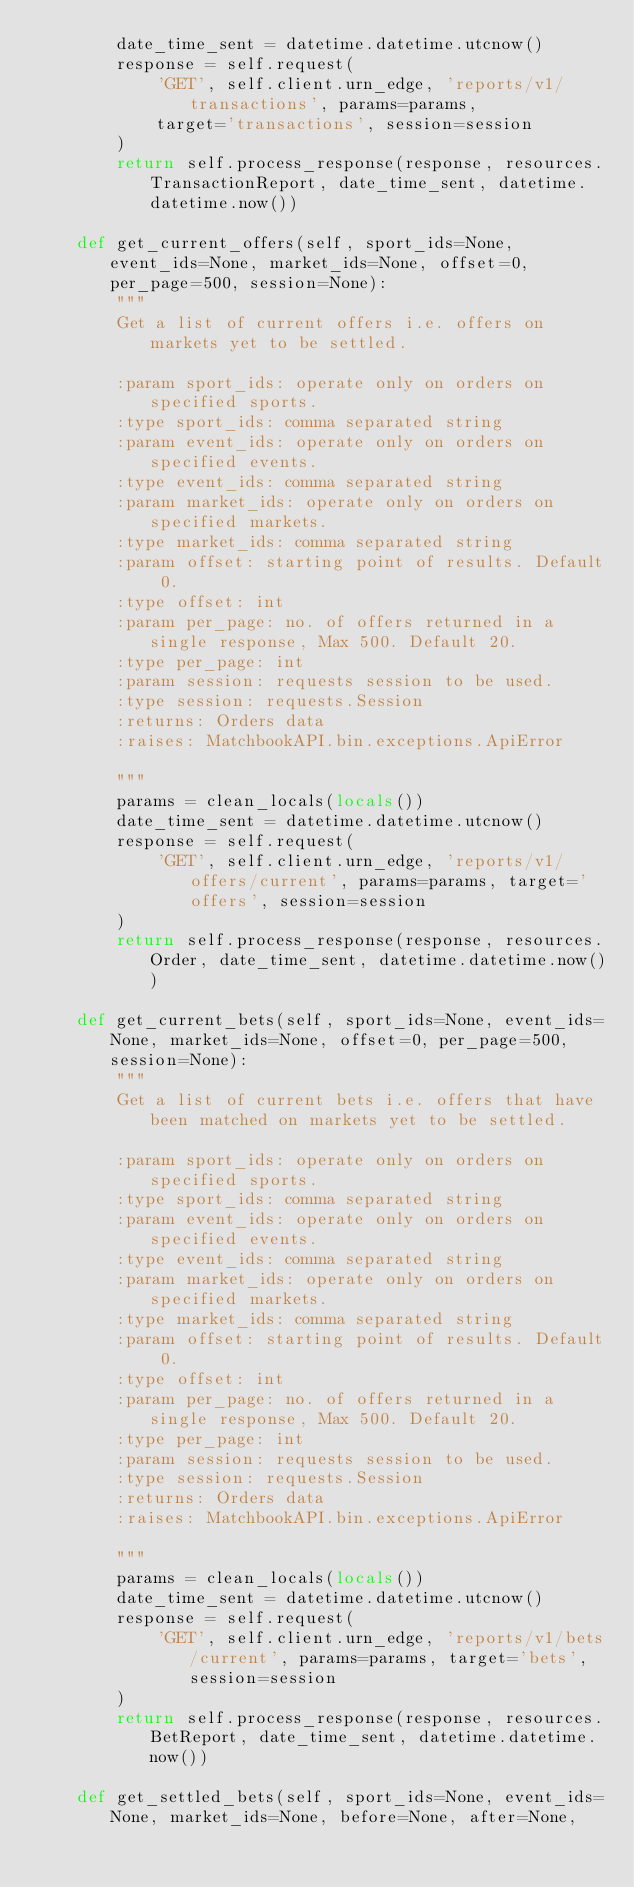<code> <loc_0><loc_0><loc_500><loc_500><_Python_>        date_time_sent = datetime.datetime.utcnow()
        response = self.request(
            'GET', self.client.urn_edge, 'reports/v1/transactions', params=params,
            target='transactions', session=session
        )
        return self.process_response(response, resources.TransactionReport, date_time_sent, datetime.datetime.now())

    def get_current_offers(self, sport_ids=None, event_ids=None, market_ids=None, offset=0, per_page=500, session=None):
        """
        Get a list of current offers i.e. offers on markets yet to be settled.
        
        :param sport_ids: operate only on orders on specified sports.
        :type sport_ids: comma separated string
        :param event_ids: operate only on orders on specified events.
        :type event_ids: comma separated string
        :param market_ids: operate only on orders on specified markets.
        :type market_ids: comma separated string
        :param offset: starting point of results. Default 0.
        :type offset: int
        :param per_page: no. of offers returned in a single response, Max 500. Default 20.
        :type per_page: int
        :param session: requests session to be used.
        :type session: requests.Session
        :returns: Orders data
        :raises: MatchbookAPI.bin.exceptions.ApiError

        """
        params = clean_locals(locals())
        date_time_sent = datetime.datetime.utcnow()
        response = self.request(
            'GET', self.client.urn_edge, 'reports/v1/offers/current', params=params, target='offers', session=session
        )
        return self.process_response(response, resources.Order, date_time_sent, datetime.datetime.now())

    def get_current_bets(self, sport_ids=None, event_ids=None, market_ids=None, offset=0, per_page=500, session=None):
        """
        Get a list of current bets i.e. offers that have been matched on markets yet to be settled.
        
        :param sport_ids: operate only on orders on specified sports.
        :type sport_ids: comma separated string
        :param event_ids: operate only on orders on specified events.
        :type event_ids: comma separated string
        :param market_ids: operate only on orders on specified markets.
        :type market_ids: comma separated string
        :param offset: starting point of results. Default 0.
        :type offset: int
        :param per_page: no. of offers returned in a single response, Max 500. Default 20.
        :type per_page: int
        :param session: requests session to be used.
        :type session: requests.Session
        :returns: Orders data
        :raises: MatchbookAPI.bin.exceptions.ApiError

        """
        params = clean_locals(locals())
        date_time_sent = datetime.datetime.utcnow()
        response = self.request(
            'GET', self.client.urn_edge, 'reports/v1/bets/current', params=params, target='bets', session=session
        )
        return self.process_response(response, resources.BetReport, date_time_sent, datetime.datetime.now())

    def get_settled_bets(self, sport_ids=None, event_ids=None, market_ids=None, before=None, after=None,</code> 